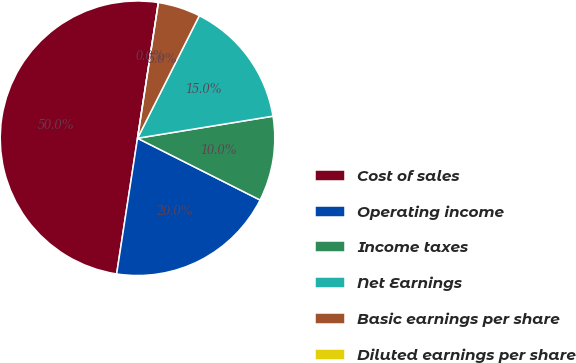Convert chart to OTSL. <chart><loc_0><loc_0><loc_500><loc_500><pie_chart><fcel>Cost of sales<fcel>Operating income<fcel>Income taxes<fcel>Net Earnings<fcel>Basic earnings per share<fcel>Diluted earnings per share<nl><fcel>50.0%<fcel>20.0%<fcel>10.0%<fcel>15.0%<fcel>5.0%<fcel>0.0%<nl></chart> 